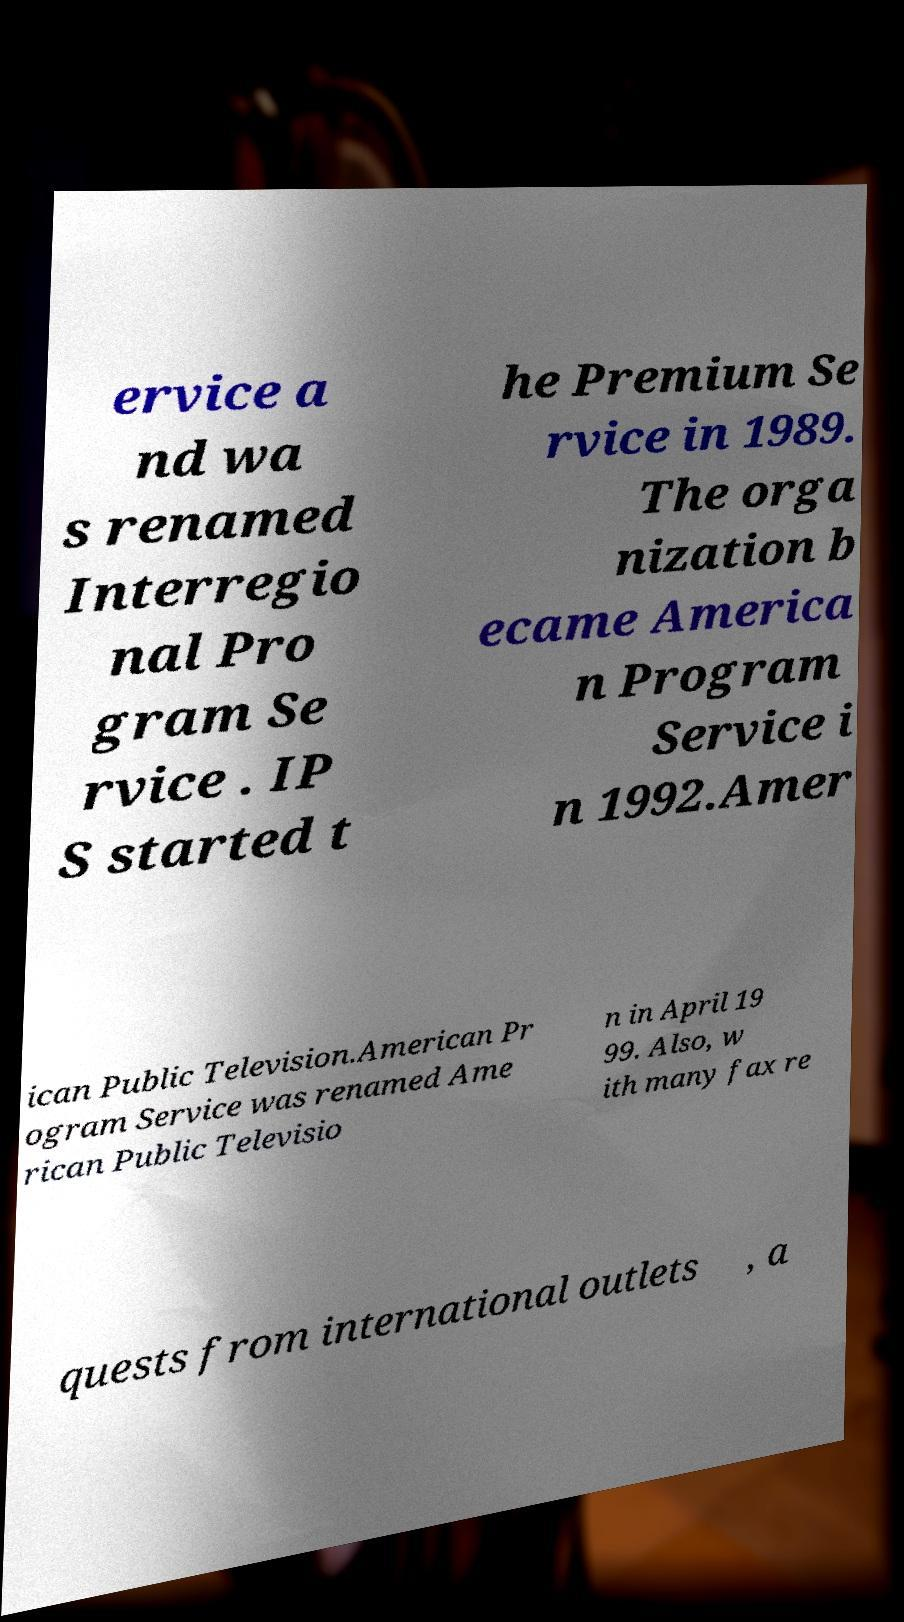Can you accurately transcribe the text from the provided image for me? ervice a nd wa s renamed Interregio nal Pro gram Se rvice . IP S started t he Premium Se rvice in 1989. The orga nization b ecame America n Program Service i n 1992.Amer ican Public Television.American Pr ogram Service was renamed Ame rican Public Televisio n in April 19 99. Also, w ith many fax re quests from international outlets , a 